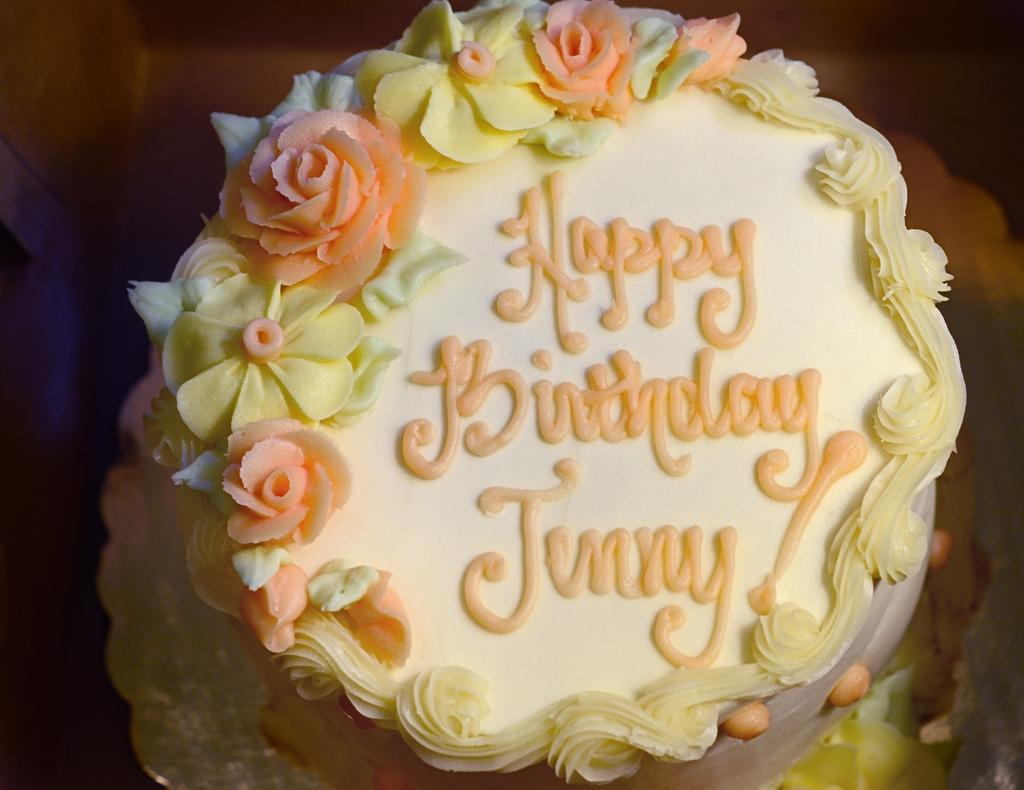What is: What is the main subject of the image? The main subject of the image is a cake. What message is written on the cake? The cake has "happy birthday" wishes on it. What unit of measurement is used to compare the size of the cake to the size of a form in the image? There is no form present in the image, and therefore no comparison can be made. 